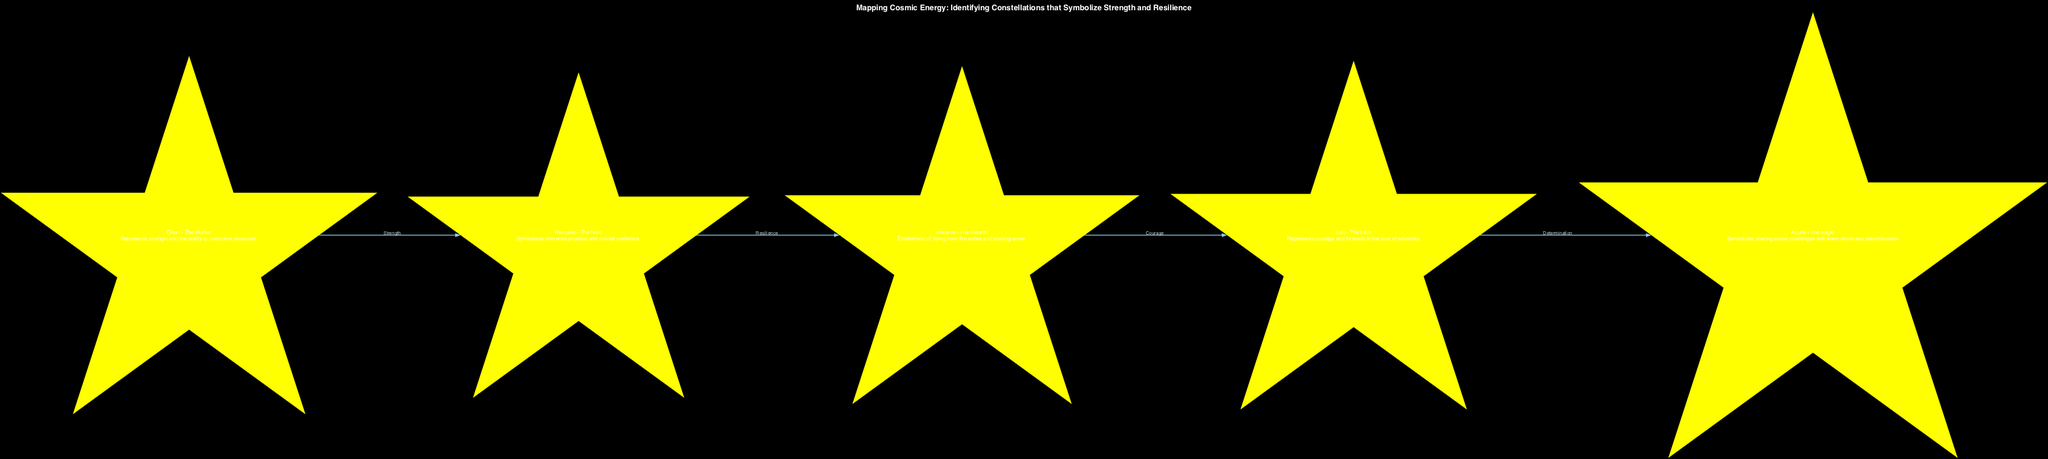What is the title of the diagram? The title is explicitly stated in the diagram, summarizing the main theme or purpose of the visualization. In this case, the title is "Mapping Cosmic Energy: Identifying Constellations that Symbolize Strength and Resilience."
Answer: Mapping Cosmic Energy: Identifying Constellations that Symbolize Strength and Resilience How many constellations are represented in the diagram? By counting the nodes listed in the diagram data, we find that there are five constellations depicted.
Answer: 5 What does the constellation Orion symbolize? Orion's description directly states its symbolism, which is associated with overcoming challenges and strength.
Answer: Strength and the ability to overcome obstacles Which constellation is connected to Phoenix? The edges show connections between constellations. The one leading into Phoenix is from Hercules, indicating that Hercules connects to Phoenix in the cosmic narrative of resilience.
Answer: Hercules What relationship connects Leo and Aquila? The diagram shows an edge from Leo to Aquila labeled "Determination," which defines the connection between these two constellations.
Answer: Determination What is the significance of the Phoenix constellation? According to its description within the diagram, the Phoenix symbolizes the theme of renewal and rebirth, embodying starting over after setbacks.
Answer: Rising from the ashes and starting anew Which constellation symbolizes immense physical and mental resilience? The description for the constellation Hercules highlights its representation of both physical and mental resilience explicitly.
Answer: Hercules How is the relationship between Orion and Hercules characterized? The edge connecting Orion to Hercules is labeled "Strength," indicating the nature of the connection between these two constellations as one of empowerment.
Answer: Strength 